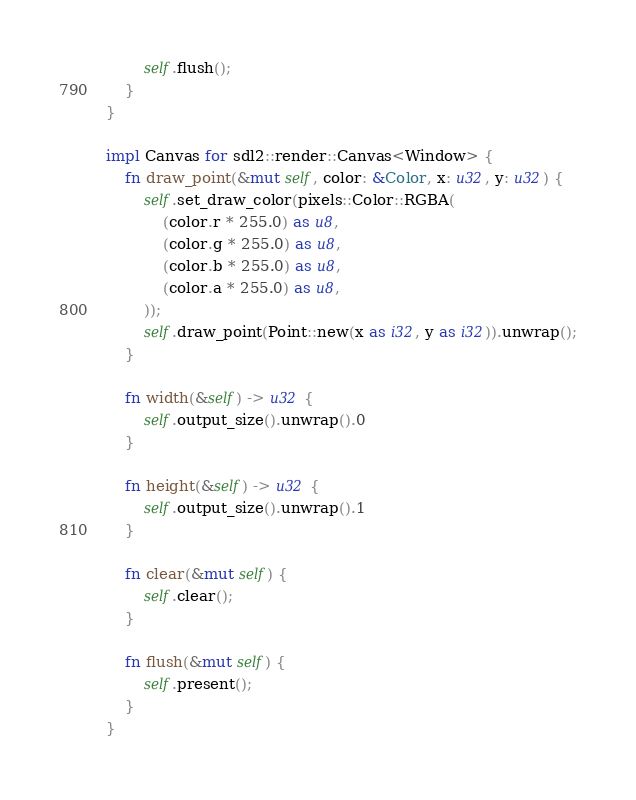<code> <loc_0><loc_0><loc_500><loc_500><_Rust_>        self.flush();
    }
}

impl Canvas for sdl2::render::Canvas<Window> {
    fn draw_point(&mut self, color: &Color, x: u32, y: u32) {
        self.set_draw_color(pixels::Color::RGBA(
            (color.r * 255.0) as u8,
            (color.g * 255.0) as u8,
            (color.b * 255.0) as u8,
            (color.a * 255.0) as u8,
        ));
        self.draw_point(Point::new(x as i32, y as i32)).unwrap();
    }

    fn width(&self) -> u32 {
        self.output_size().unwrap().0
    }

    fn height(&self) -> u32 {
        self.output_size().unwrap().1
    }

    fn clear(&mut self) {
        self.clear();
    }

    fn flush(&mut self) {
        self.present();
    }
}
</code> 